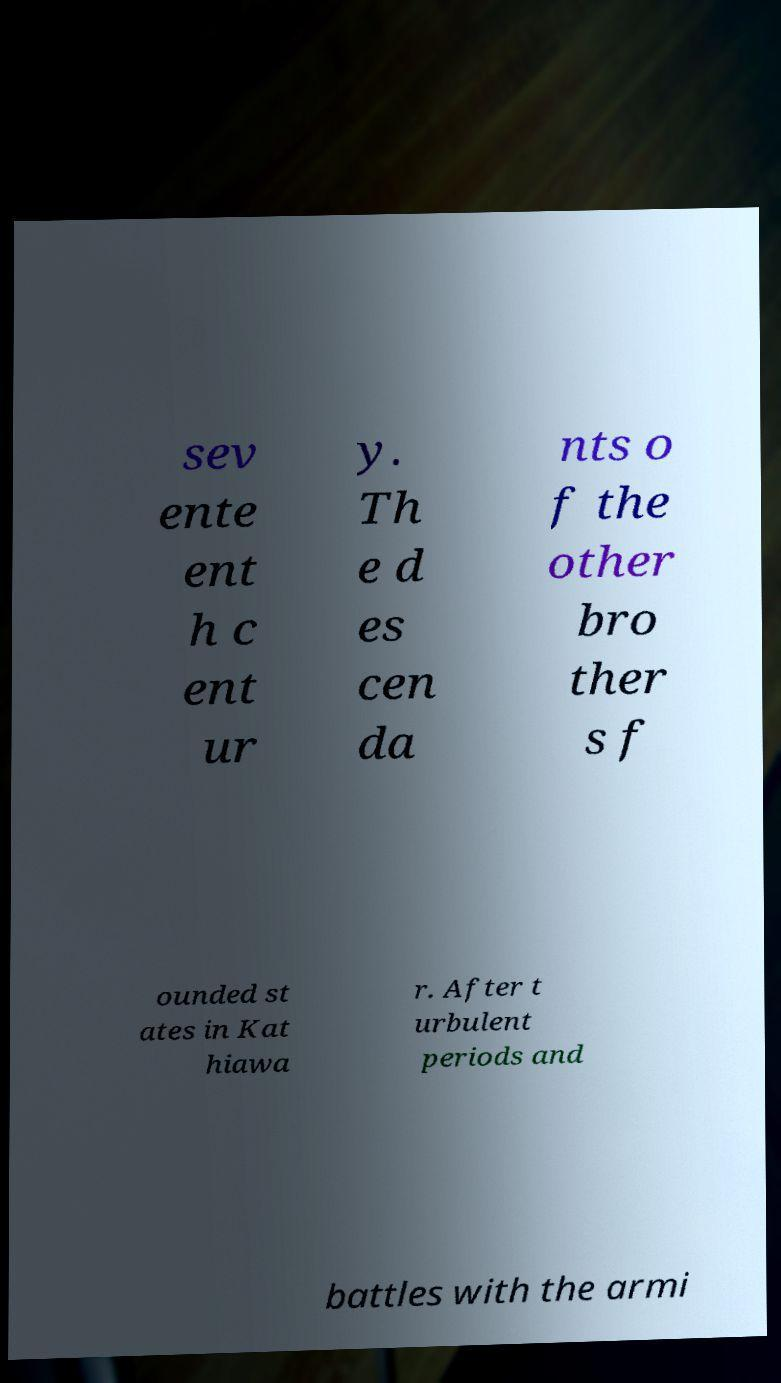Please read and relay the text visible in this image. What does it say? sev ente ent h c ent ur y. Th e d es cen da nts o f the other bro ther s f ounded st ates in Kat hiawa r. After t urbulent periods and battles with the armi 